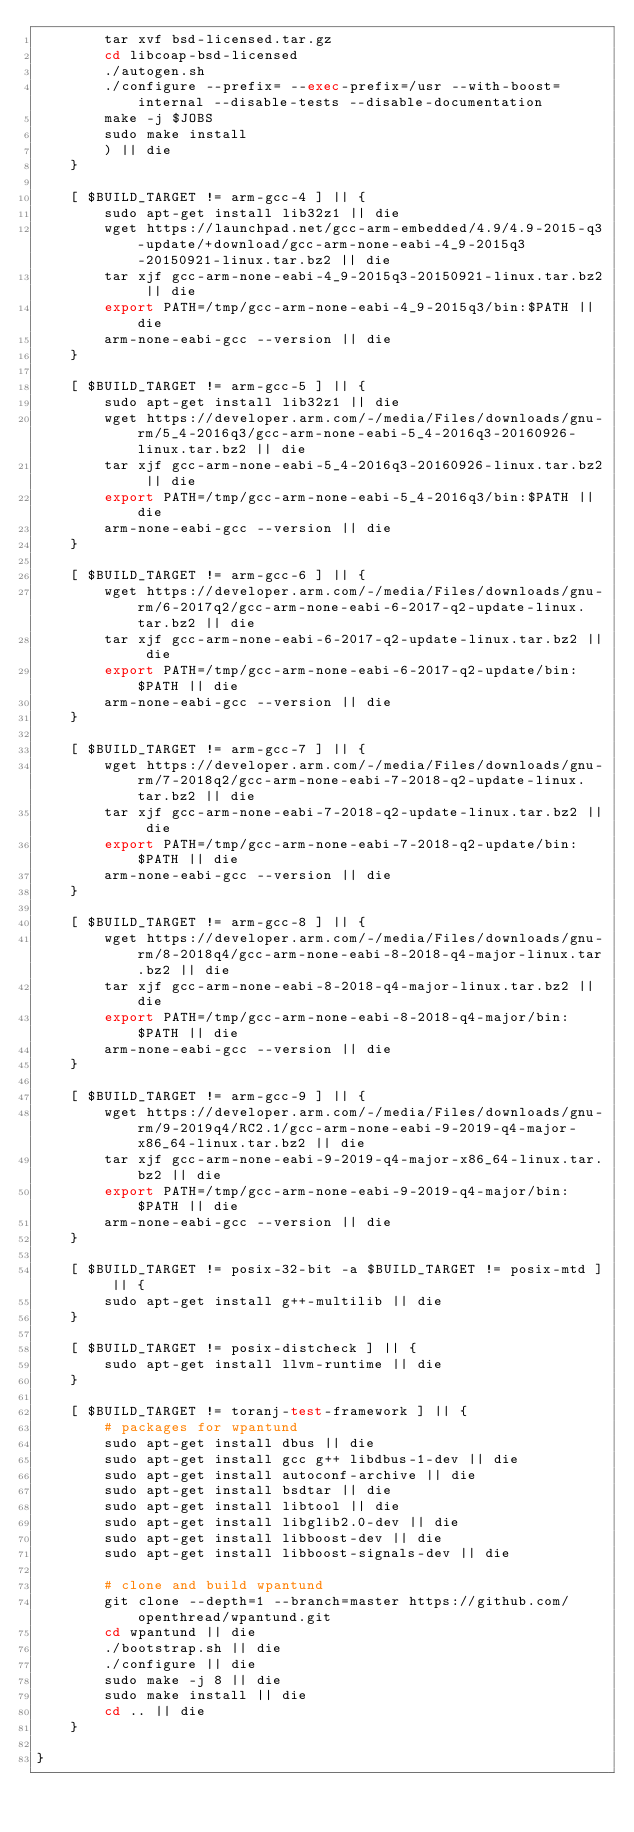<code> <loc_0><loc_0><loc_500><loc_500><_Bash_>        tar xvf bsd-licensed.tar.gz
        cd libcoap-bsd-licensed
        ./autogen.sh
        ./configure --prefix= --exec-prefix=/usr --with-boost=internal --disable-tests --disable-documentation
        make -j $JOBS
        sudo make install
        ) || die
    }

    [ $BUILD_TARGET != arm-gcc-4 ] || {
        sudo apt-get install lib32z1 || die
        wget https://launchpad.net/gcc-arm-embedded/4.9/4.9-2015-q3-update/+download/gcc-arm-none-eabi-4_9-2015q3-20150921-linux.tar.bz2 || die
        tar xjf gcc-arm-none-eabi-4_9-2015q3-20150921-linux.tar.bz2 || die
        export PATH=/tmp/gcc-arm-none-eabi-4_9-2015q3/bin:$PATH || die
        arm-none-eabi-gcc --version || die
    }

    [ $BUILD_TARGET != arm-gcc-5 ] || {
        sudo apt-get install lib32z1 || die
        wget https://developer.arm.com/-/media/Files/downloads/gnu-rm/5_4-2016q3/gcc-arm-none-eabi-5_4-2016q3-20160926-linux.tar.bz2 || die
        tar xjf gcc-arm-none-eabi-5_4-2016q3-20160926-linux.tar.bz2 || die
        export PATH=/tmp/gcc-arm-none-eabi-5_4-2016q3/bin:$PATH || die
        arm-none-eabi-gcc --version || die
    }

    [ $BUILD_TARGET != arm-gcc-6 ] || {
        wget https://developer.arm.com/-/media/Files/downloads/gnu-rm/6-2017q2/gcc-arm-none-eabi-6-2017-q2-update-linux.tar.bz2 || die
        tar xjf gcc-arm-none-eabi-6-2017-q2-update-linux.tar.bz2 || die
        export PATH=/tmp/gcc-arm-none-eabi-6-2017-q2-update/bin:$PATH || die
        arm-none-eabi-gcc --version || die
    }

    [ $BUILD_TARGET != arm-gcc-7 ] || {
        wget https://developer.arm.com/-/media/Files/downloads/gnu-rm/7-2018q2/gcc-arm-none-eabi-7-2018-q2-update-linux.tar.bz2 || die
        tar xjf gcc-arm-none-eabi-7-2018-q2-update-linux.tar.bz2 || die
        export PATH=/tmp/gcc-arm-none-eabi-7-2018-q2-update/bin:$PATH || die
        arm-none-eabi-gcc --version || die
    }

    [ $BUILD_TARGET != arm-gcc-8 ] || {
        wget https://developer.arm.com/-/media/Files/downloads/gnu-rm/8-2018q4/gcc-arm-none-eabi-8-2018-q4-major-linux.tar.bz2 || die
        tar xjf gcc-arm-none-eabi-8-2018-q4-major-linux.tar.bz2 || die
        export PATH=/tmp/gcc-arm-none-eabi-8-2018-q4-major/bin:$PATH || die
        arm-none-eabi-gcc --version || die
    }

    [ $BUILD_TARGET != arm-gcc-9 ] || {
        wget https://developer.arm.com/-/media/Files/downloads/gnu-rm/9-2019q4/RC2.1/gcc-arm-none-eabi-9-2019-q4-major-x86_64-linux.tar.bz2 || die
        tar xjf gcc-arm-none-eabi-9-2019-q4-major-x86_64-linux.tar.bz2 || die
        export PATH=/tmp/gcc-arm-none-eabi-9-2019-q4-major/bin:$PATH || die
        arm-none-eabi-gcc --version || die
    }

    [ $BUILD_TARGET != posix-32-bit -a $BUILD_TARGET != posix-mtd ] || {
        sudo apt-get install g++-multilib || die
    }

    [ $BUILD_TARGET != posix-distcheck ] || {
        sudo apt-get install llvm-runtime || die
    }

    [ $BUILD_TARGET != toranj-test-framework ] || {
        # packages for wpantund
        sudo apt-get install dbus || die
        sudo apt-get install gcc g++ libdbus-1-dev || die
        sudo apt-get install autoconf-archive || die
        sudo apt-get install bsdtar || die
        sudo apt-get install libtool || die
        sudo apt-get install libglib2.0-dev || die
        sudo apt-get install libboost-dev || die
        sudo apt-get install libboost-signals-dev || die

        # clone and build wpantund
        git clone --depth=1 --branch=master https://github.com/openthread/wpantund.git
        cd wpantund || die
        ./bootstrap.sh || die
        ./configure || die
        sudo make -j 8 || die
        sudo make install || die
        cd .. || die
    }

}
</code> 